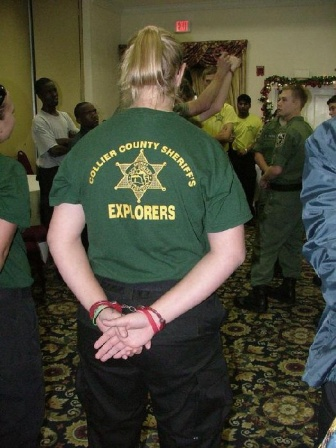Create a short mystery story based on the image. In the heart of Collier County, a small community center bustles with holiday cheer. But beneath the surface of festive decorations, an air of mystery lingers. The Sheriff's Explorers program has gathered for their annual holiday party. Among them, Charlotte, a young deputy with a keen eye, stands quietly, observing the group. Her green t-shirt marks her as one of the Explorers, yet she’s there on a secret mission. 

Just days before, valuable evidence had gone missing from the station—documents crucial to an ongoing investigation. Whispers suggested that the perpetrator might be among the attendees. As music plays and laughter fills the room, Charlotte keeps a watchful eye on each interaction, searching for any suspicious behavior. 

Then, she notices it—a brief, almost imperceptible exchange between two individuals, a slight nod, a handoff of a festive gift bag. Charlotte’s heart quickens. With careful precision, she moves through the room, her every step blending into the holiday hustle. 

Finally, as she reaches the two suspects, she skillfully intercepts the exchange, revealing the missing documents cleverly disguised as holiday cards. The room falls silent as the realization dawns. The holiday party had masked the perfect opportunity for deceit, but Charlotte’s quick thinking ensures that justice prevails, adding an unexpected twist to the holiday festivities. 